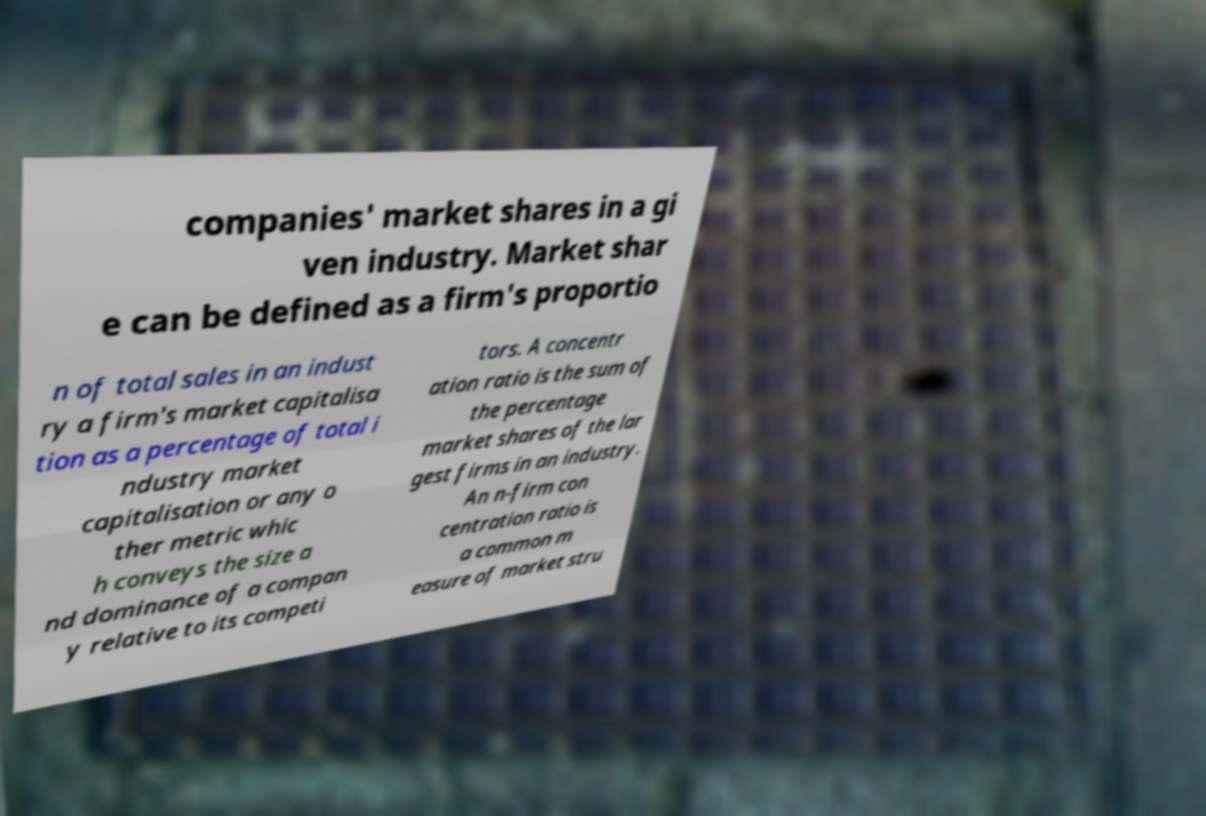What messages or text are displayed in this image? I need them in a readable, typed format. companies' market shares in a gi ven industry. Market shar e can be defined as a firm's proportio n of total sales in an indust ry a firm's market capitalisa tion as a percentage of total i ndustry market capitalisation or any o ther metric whic h conveys the size a nd dominance of a compan y relative to its competi tors. A concentr ation ratio is the sum of the percentage market shares of the lar gest firms in an industry. An n-firm con centration ratio is a common m easure of market stru 